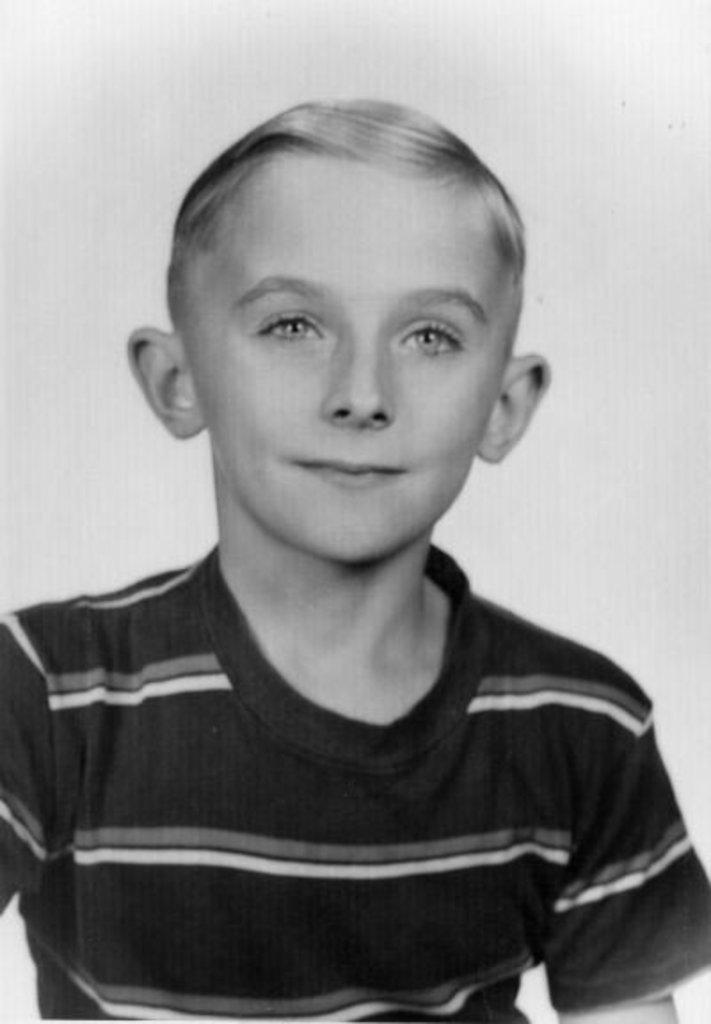What is the main subject of the image? The main subject of the image is a boy. What is the boy's facial expression in the image? The boy is smiling in the image. What is the boy looking at in the image? The boy is looking at something, but we cannot determine what it is from the provided facts. What type of chain is the boy holding in the image? There is no chain present in the image; the boy is simply looking at something. How many cups can be seen in the image? There are no cups present in the image. 